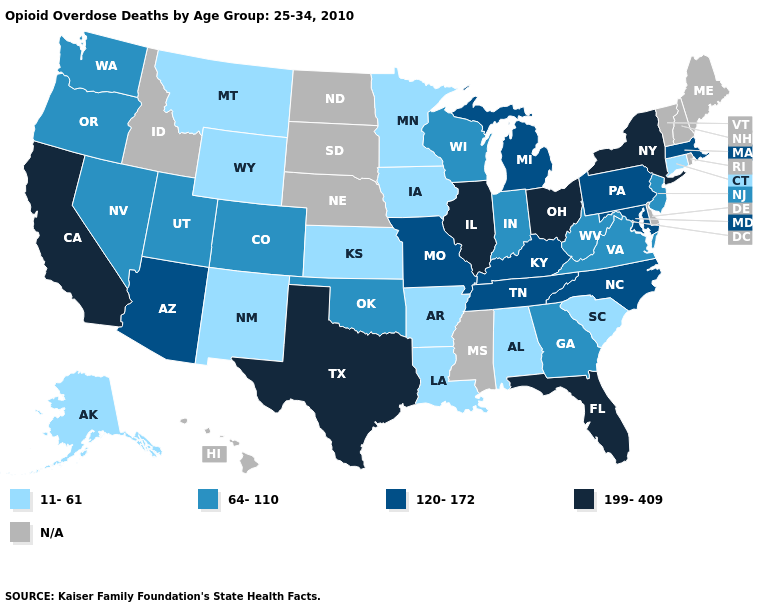Which states have the highest value in the USA?
Answer briefly. California, Florida, Illinois, New York, Ohio, Texas. Name the states that have a value in the range 11-61?
Concise answer only. Alabama, Alaska, Arkansas, Connecticut, Iowa, Kansas, Louisiana, Minnesota, Montana, New Mexico, South Carolina, Wyoming. Name the states that have a value in the range 11-61?
Answer briefly. Alabama, Alaska, Arkansas, Connecticut, Iowa, Kansas, Louisiana, Minnesota, Montana, New Mexico, South Carolina, Wyoming. Name the states that have a value in the range 64-110?
Answer briefly. Colorado, Georgia, Indiana, Nevada, New Jersey, Oklahoma, Oregon, Utah, Virginia, Washington, West Virginia, Wisconsin. Which states have the lowest value in the Northeast?
Keep it brief. Connecticut. Does the first symbol in the legend represent the smallest category?
Keep it brief. Yes. Does the first symbol in the legend represent the smallest category?
Quick response, please. Yes. Does the first symbol in the legend represent the smallest category?
Give a very brief answer. Yes. Is the legend a continuous bar?
Be succinct. No. Name the states that have a value in the range 11-61?
Short answer required. Alabama, Alaska, Arkansas, Connecticut, Iowa, Kansas, Louisiana, Minnesota, Montana, New Mexico, South Carolina, Wyoming. Name the states that have a value in the range 11-61?
Write a very short answer. Alabama, Alaska, Arkansas, Connecticut, Iowa, Kansas, Louisiana, Minnesota, Montana, New Mexico, South Carolina, Wyoming. Does Kentucky have the lowest value in the USA?
Give a very brief answer. No. Does Montana have the lowest value in the USA?
Keep it brief. Yes. What is the lowest value in the Northeast?
Concise answer only. 11-61. 